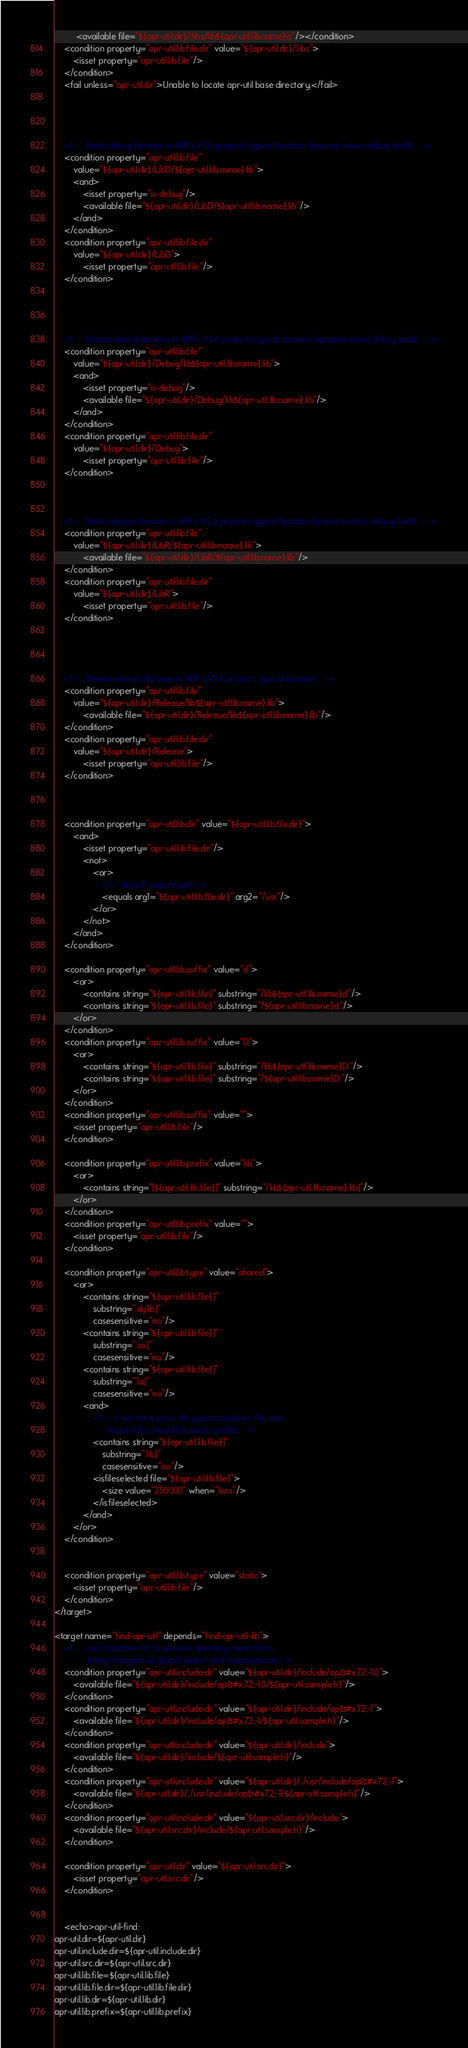Convert code to text. <code><loc_0><loc_0><loc_500><loc_500><_XML_>	     <available file="${apr-util.dir}/.libs/lib${apr-util.lib.name}.a"/></condition>
	<condition property="apr-util.lib.file.dir" value="${apr-util.dir}/.libs">
		<isset property="apr-util.lib.file"/>
	</condition>
    <fail unless="apr-util.dir">Unable to locate apr-util base directory.</fail>
    



	<!--   Static debug libraries in APR's VC6 projects typical location (ignored unless debug build)   -->
	<condition property="apr-util.lib.file"
		value="${apr-util.dir}/LibD/${apr-util.lib.name}.lib">
		<and>
			<isset property="is-debug"/>
			<available file="${apr-util.dir}/LibD/${apr-util.lib.name}.lib"/>
		</and>
	</condition>
	<condition property="apr-util.lib.file.dir"
		value="${apr-util.dir}/LibD">
			<isset property="apr-util.lib.file"/>
	</condition>




	<!--   Shared debug libraries in APR's VC6 projects typical location (ignored unless debug build)   -->
	<condition property="apr-util.lib.file"
		value="${apr-util.dir}/Debug/lib${apr-util.lib.name}.lib">
		<and>
			<isset property="is-debug"/>
			<available file="${apr-util.dir}/Debug/lib${apr-util.lib.name}.lib"/>
		</and>
	</condition>
	<condition property="apr-util.lib.file.dir"
		value="${apr-util.dir}/Debug">
			<isset property="apr-util.lib.file"/>
	</condition>



	<!--   Static release libraries in APR's VC6 projects typical location (ignored unless debug build)   -->
	<condition property="apr-util.lib.file"
		value="${apr-util.dir}/LibR/${apr-util.lib.name}.lib">
			<available file="${apr-util.dir}/LibR/${apr-util.lib.name}.lib"/>
	</condition>
	<condition property="apr-util.lib.file.dir"
		value="${apr-util.dir}/LibR">
			<isset property="apr-util.lib.file"/>
	</condition>




	<!--   Shared release libraries in APR's VC6 projects typical location   -->
	<condition property="apr-util.lib.file"
		value="${apr-util.dir}/Release/lib${apr-util.lib.name}.lib">
			<available file="${apr-util.dir}/Release/lib${apr-util.lib.name}.lib"/>
	</condition>
	<condition property="apr-util.lib.file.dir"
		value="${apr-util.dir}/Release">
			<isset property="apr-util.lib.file"/>
	</condition>



	<condition property="apr-util.lib.dir" value="${apr-util.lib.file.dir}">
		<and>
			<isset property="apr-util.lib.file.dir"/>
			<not>
				<or>
					<!--  default search path -->
					<equals arg1="${apr-util.lib.file.dir}" arg2="/usr"/>
				</or>
			</not>
		</and>
	</condition>

	<condition property="apr-util.lib.suffix" value="d">
		<or>
			<contains string="${apr-util.lib.file}" substring="/lib${apr-util.lib.name}d."/>
			<contains string="${apr-util.lib.file}" substring="/${apr-util.lib.name}d."/>
		</or>
	</condition>
	<condition property="apr-util.lib.suffix" value="D">
		<or>
			<contains string="${apr-util.lib.file}" substring="/lib${apr-util.lib.name}D."/>
			<contains string="${apr-util.lib.file}" substring="/${apr-util.lib.name}D."/>
		</or>
	</condition>
	<condition property="apr-util.lib.suffix" value="">
		<isset property="apr-util.lib.file"/>
	</condition>

	<condition property="apr-util.lib.prefix" value="lib">
		<or>
			<contains string="[${apr-util.lib.file}]" substring="/lib${apr-util.lib.name}.lib]"/>
		</or>
	</condition>
	<condition property="apr-util.lib.prefix" value="">
		<isset property="apr-util.lib.file"/>
	</condition>

	<condition property="apr-util.lib.type" value="shared">
		<or>
			<contains string="${apr-util.lib.file}]" 
				substring=".dylib]" 
				casesensitive="no"/>
			<contains string="${apr-util.lib.file}]" 
				substring=".so]" 
				casesensitive="no"/>
			<contains string="${apr-util.lib.file}]" 
				substring=".la]" 
				casesensitive="no"/>
			<and>
				<!--   if we have just a .lib, guess based on file size.
				      Import libs should be much smaller.  -->
				<contains string="${apr-util.lib.file}]" 
					substring=".lib]" 
					casesensitive="no"/>
				<isfileselected file="${apr-util.lib.file}">
					<size value="250000" when="less"/>
				</isfileselected>
			</and>
		</or>
	</condition>


	<condition property="apr-util.lib.type" value="static">
		<isset property="apr-util.lib.file"/>
	</condition>
</target>

<target name="find-apr-util" depends="find-apr-util-lib">
	<!--   use character ref to prevent directory name from
	          being changed on global search and replacements -->
    <condition property="apr-util.include.dir" value="${apr-util.dir}/include/ap&#x72;-1.0">
        <available file="${apr-util.dir}/include/ap&#x72;-1.0/${apr-util.sample.h}"/>
    </condition>
    <condition property="apr-util.include.dir" value="${apr-util.dir}/include/ap&#x72;-1">
        <available file="${apr-util.dir}/include/ap&#x72;-1/${apr-util.sample.h}"/>
    </condition>
    <condition property="apr-util.include.dir" value="${apr-util.dir}/include">
        <available file="${apr-util.dir}/include/${apr-util.sample.h}"/>
    </condition>
    <condition property="apr-util.include.dir" value="${apr-util.dir}/../usr/include/ap&#x72;-1">
        <available file="${apr-util.dir}/../usr/include/ap&#x72;-1/${apr-util.sample.h}"/>
    </condition>
    <condition property="apr-util.include.dir" value="${apr-util.src.dir}/include">
        <available file="${apr-util.src.dir}/include/${apr-util.sample.h}"/>
    </condition>

	<condition property="apr-util.dir" value="${apr-util.src.dir}">
		<isset property="apr-util.src.dir"/>
	</condition>


	<echo>apr-util-find:
apr-util.dir=${apr-util.dir}
apr-util.include.dir=${apr-util.include.dir}
apr-util.src.dir=${apr-util.src.dir}
apr-util.lib.file=${apr-util.lib.file}
apr-util.lib.file.dir=${apr-util.lib.file.dir}
apr-util.lib.dir=${apr-util.lib.dir}
apr-util.lib.prefix=${apr-util.lib.prefix}</code> 